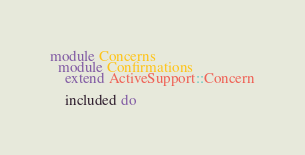<code> <loc_0><loc_0><loc_500><loc_500><_Ruby_>module Concerns
  module Confirmations
    extend ActiveSupport::Concern

    included do</code> 